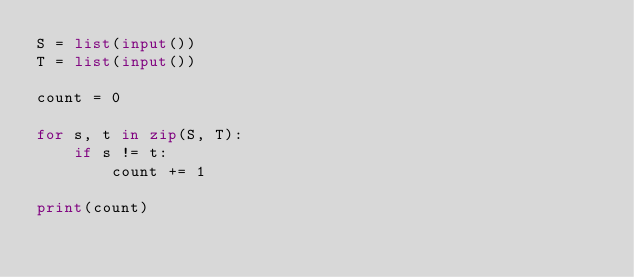Convert code to text. <code><loc_0><loc_0><loc_500><loc_500><_Python_>S = list(input())
T = list(input())

count = 0

for s, t in zip(S, T):
    if s != t:
        count += 1

print(count)</code> 